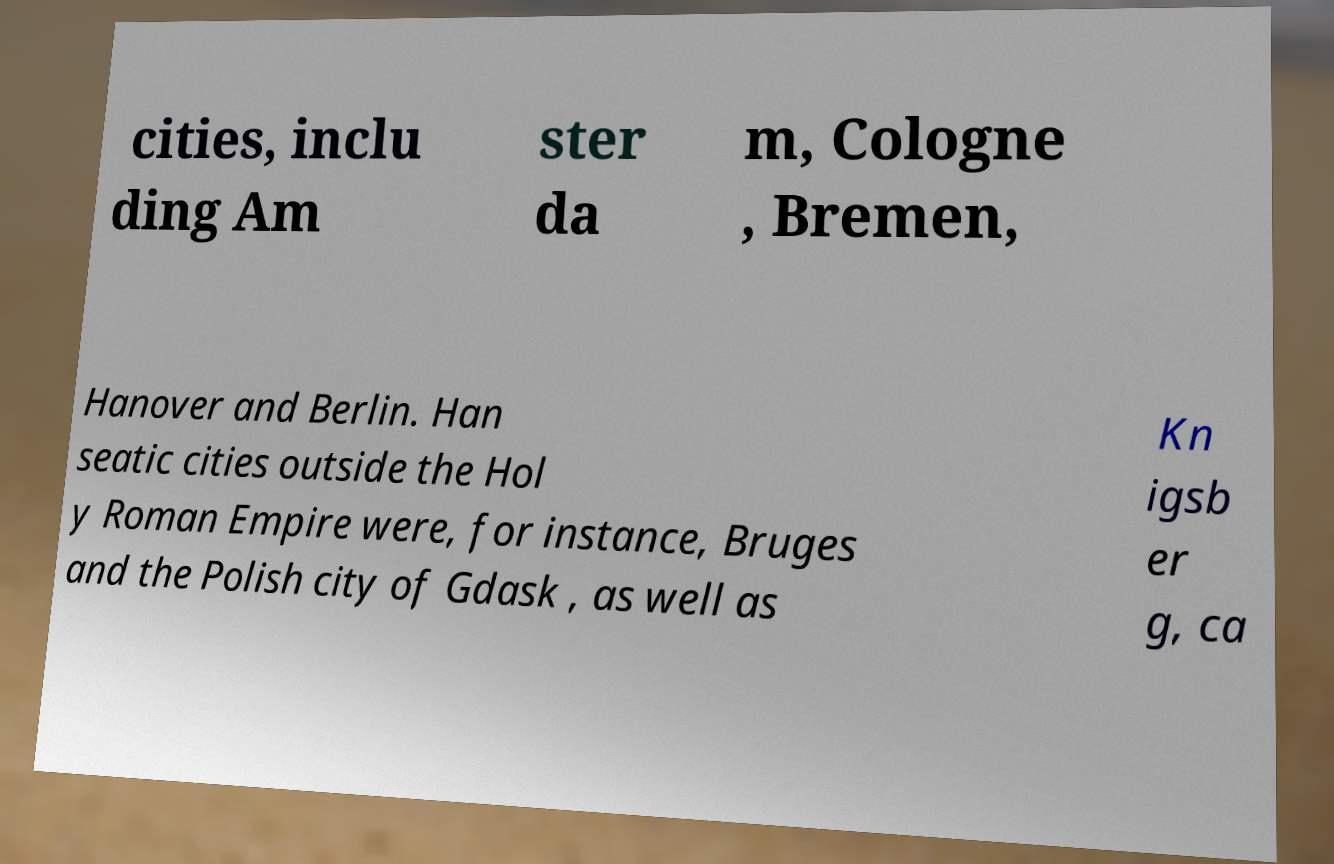Please read and relay the text visible in this image. What does it say? cities, inclu ding Am ster da m, Cologne , Bremen, Hanover and Berlin. Han seatic cities outside the Hol y Roman Empire were, for instance, Bruges and the Polish city of Gdask , as well as Kn igsb er g, ca 